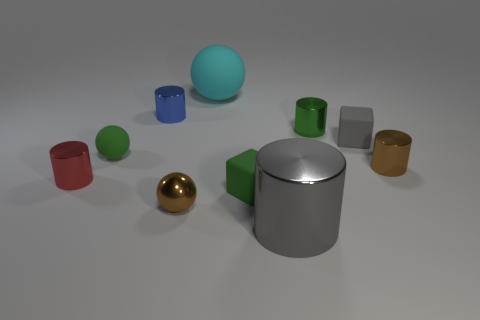Is there any other thing that is made of the same material as the large cyan thing?
Your response must be concise. Yes. How many big gray objects are on the left side of the small brown metallic ball?
Your response must be concise. 0. What is the size of the other green matte thing that is the same shape as the big rubber object?
Your answer should be very brief. Small. There is a thing that is both left of the large gray metallic thing and right of the cyan matte ball; what is its size?
Your response must be concise. Small. There is a big shiny thing; is it the same color as the tiny object in front of the tiny green matte block?
Offer a very short reply. No. How many gray objects are cylinders or big objects?
Offer a terse response. 1. The gray metal object has what shape?
Offer a terse response. Cylinder. How many other things are the same shape as the gray matte object?
Give a very brief answer. 1. There is a big object behind the gray shiny cylinder; what color is it?
Ensure brevity in your answer.  Cyan. Are the gray cylinder and the small green sphere made of the same material?
Provide a succinct answer. No. 